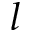<formula> <loc_0><loc_0><loc_500><loc_500>l</formula> 